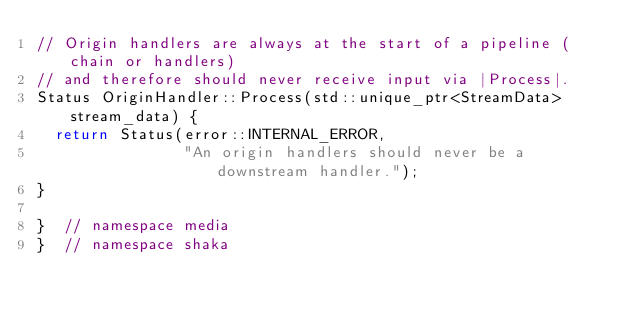Convert code to text. <code><loc_0><loc_0><loc_500><loc_500><_C++_>// Origin handlers are always at the start of a pipeline (chain or handlers)
// and therefore should never receive input via |Process|.
Status OriginHandler::Process(std::unique_ptr<StreamData> stream_data) {
  return Status(error::INTERNAL_ERROR,
                "An origin handlers should never be a downstream handler.");
}

}  // namespace media
}  // namespace shaka
</code> 